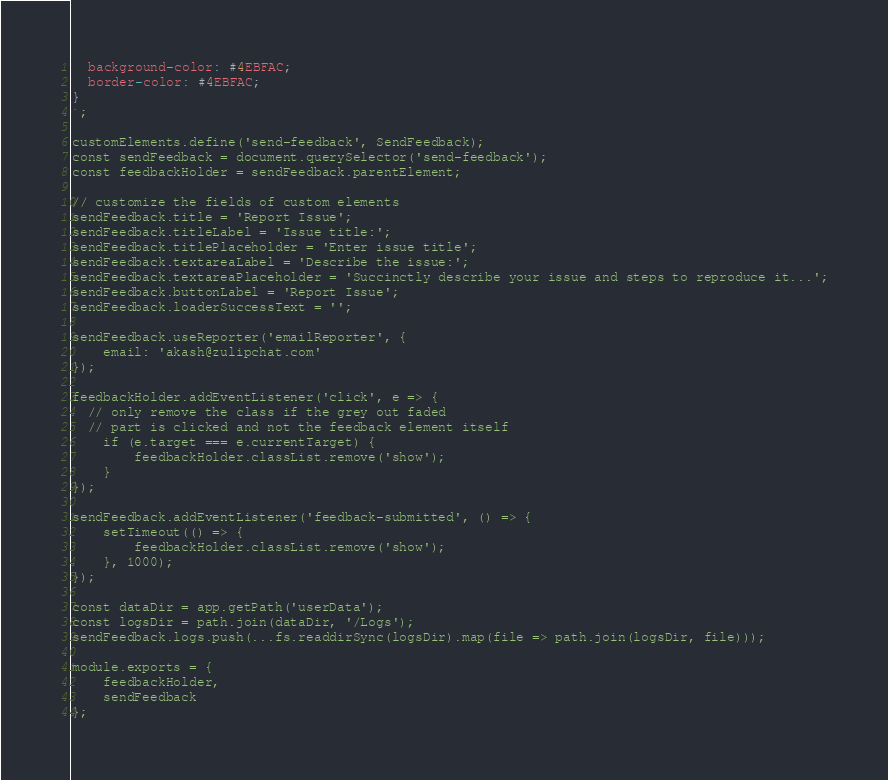Convert code to text. <code><loc_0><loc_0><loc_500><loc_500><_JavaScript_>  background-color: #4EBFAC;
  border-color: #4EBFAC;
}
`;

customElements.define('send-feedback', SendFeedback);
const sendFeedback = document.querySelector('send-feedback');
const feedbackHolder = sendFeedback.parentElement;

// customize the fields of custom elements
sendFeedback.title = 'Report Issue';
sendFeedback.titleLabel = 'Issue title:';
sendFeedback.titlePlaceholder = 'Enter issue title';
sendFeedback.textareaLabel = 'Describe the issue:';
sendFeedback.textareaPlaceholder = 'Succinctly describe your issue and steps to reproduce it...';
sendFeedback.buttonLabel = 'Report Issue';
sendFeedback.loaderSuccessText = '';

sendFeedback.useReporter('emailReporter', {
	email: 'akash@zulipchat.com'
});

feedbackHolder.addEventListener('click', e => {
  // only remove the class if the grey out faded
  // part is clicked and not the feedback element itself
	if (e.target === e.currentTarget) {
		feedbackHolder.classList.remove('show');
	}
});

sendFeedback.addEventListener('feedback-submitted', () => {
	setTimeout(() => {
		feedbackHolder.classList.remove('show');
	}, 1000);
});

const dataDir = app.getPath('userData');
const logsDir = path.join(dataDir, '/Logs');
sendFeedback.logs.push(...fs.readdirSync(logsDir).map(file => path.join(logsDir, file)));

module.exports = {
	feedbackHolder,
	sendFeedback
};
</code> 